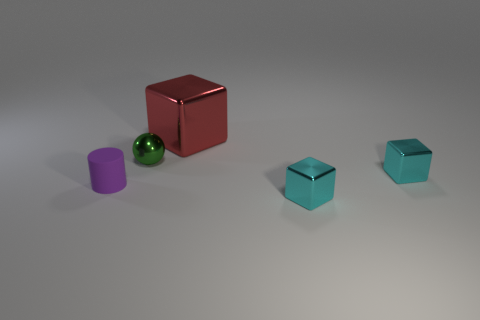Subtract all large blocks. How many blocks are left? 2 Add 4 red things. How many objects exist? 9 Subtract all cubes. How many objects are left? 2 Subtract 1 spheres. How many spheres are left? 0 Subtract all red blocks. How many blocks are left? 2 Subtract all blue balls. How many cyan blocks are left? 2 Subtract all big metallic blocks. Subtract all large red blocks. How many objects are left? 3 Add 3 small metal balls. How many small metal balls are left? 4 Add 1 big metallic objects. How many big metallic objects exist? 2 Subtract 0 yellow balls. How many objects are left? 5 